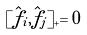Convert formula to latex. <formula><loc_0><loc_0><loc_500><loc_500>[ \hat { f } _ { i } , \hat { f } _ { j } ] _ { + } = 0</formula> 